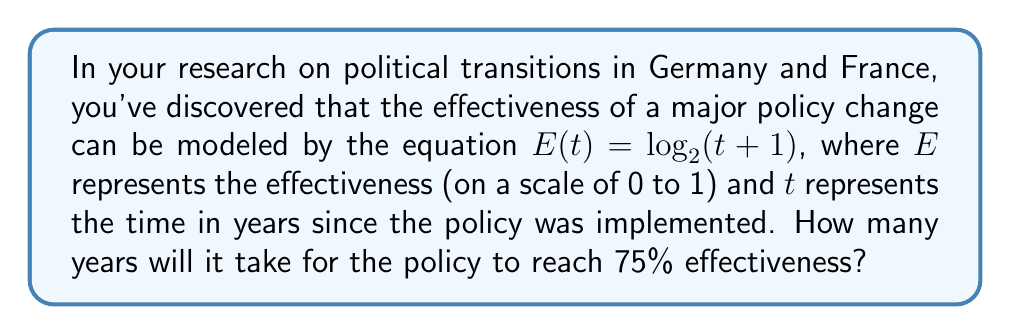Solve this math problem. To solve this problem, we'll follow these steps:

1) We're given the equation $E(t) = \log_2(t + 1)$, where we want $E(t) = 0.75$.

2) Let's substitute this into the equation:

   $0.75 = \log_2(t + 1)$

3) To solve for $t$, we need to apply the inverse function (exponential) to both sides:

   $2^{0.75} = t + 1$

4) Now we can solve for $t$:

   $t = 2^{0.75} - 1$

5) Let's calculate this value:

   $2^{0.75} \approx 1.6817928305074290$

   $t \approx 1.6817928305074290 - 1 \approx 0.6817928305074290$

6) Since $t$ represents years, we should round to a reasonable number of decimal places. Rounding to two decimal places:

   $t \approx 0.68$ years

7) To convert this to a more intuitive format, we can express it in months:

   $0.68 \times 12 \approx 8.16$ months

Therefore, it will take approximately 8 months for the policy to reach 75% effectiveness.
Answer: Approximately 8 months 